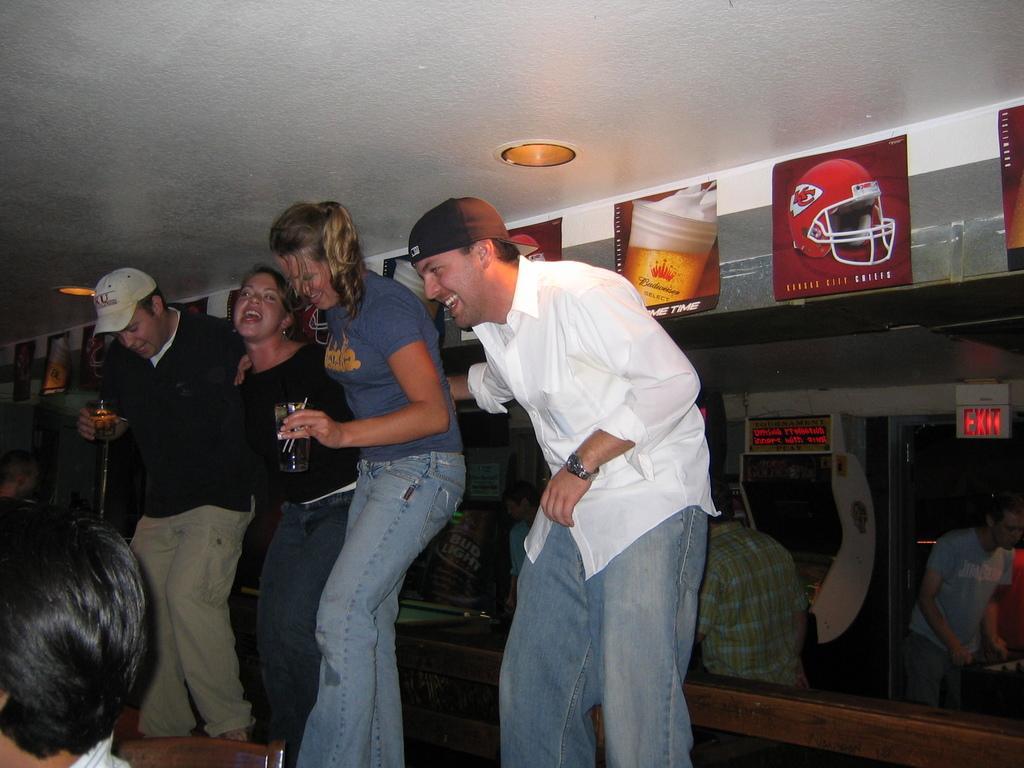In one or two sentences, can you explain what this image depicts? As we can see in the image there is wall, windows, group of people, light and posters. 